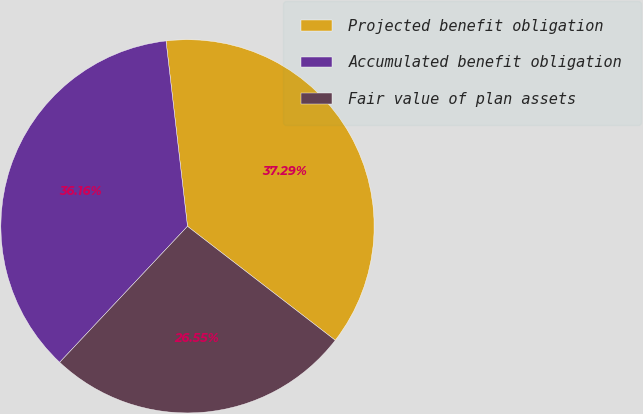Convert chart. <chart><loc_0><loc_0><loc_500><loc_500><pie_chart><fcel>Projected benefit obligation<fcel>Accumulated benefit obligation<fcel>Fair value of plan assets<nl><fcel>37.29%<fcel>36.16%<fcel>26.55%<nl></chart> 